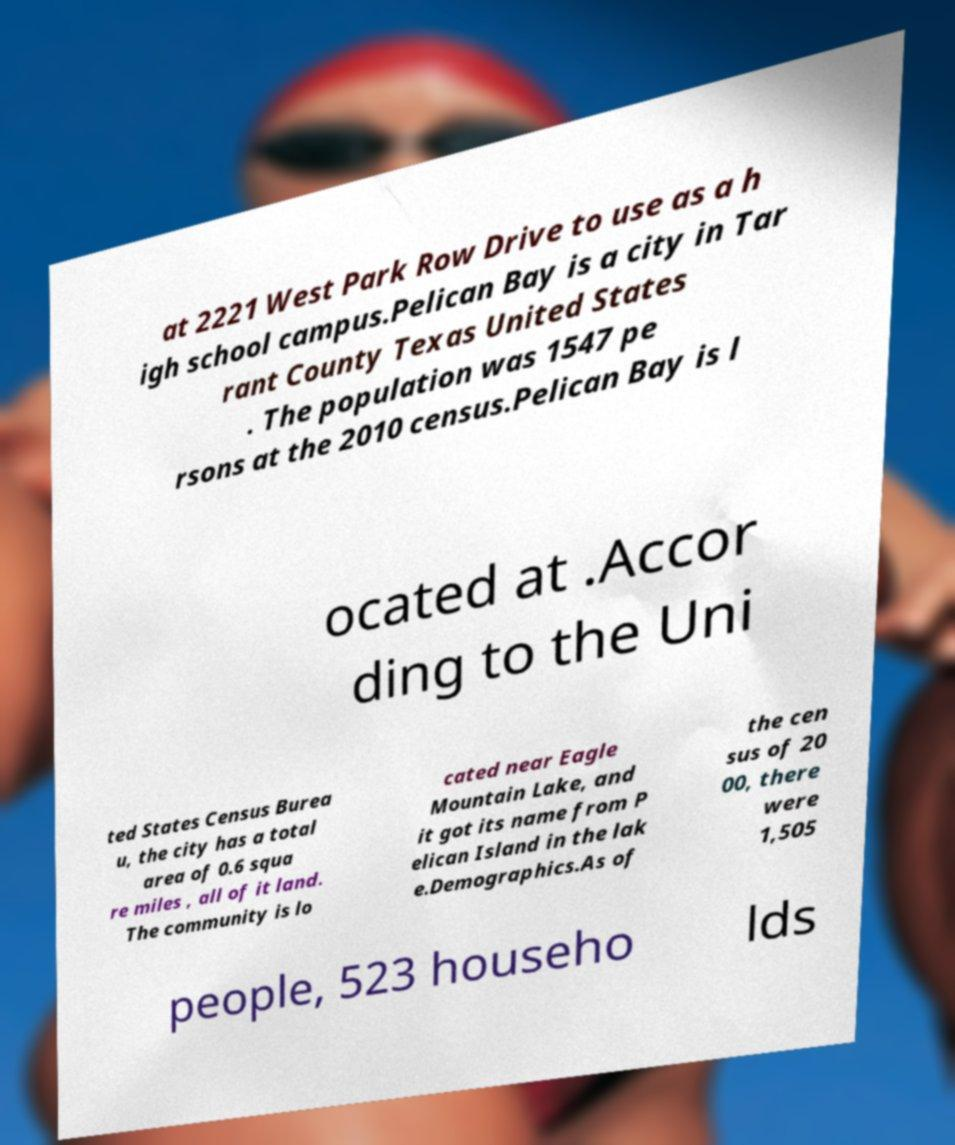Could you assist in decoding the text presented in this image and type it out clearly? at 2221 West Park Row Drive to use as a h igh school campus.Pelican Bay is a city in Tar rant County Texas United States . The population was 1547 pe rsons at the 2010 census.Pelican Bay is l ocated at .Accor ding to the Uni ted States Census Burea u, the city has a total area of 0.6 squa re miles , all of it land. The community is lo cated near Eagle Mountain Lake, and it got its name from P elican Island in the lak e.Demographics.As of the cen sus of 20 00, there were 1,505 people, 523 househo lds 